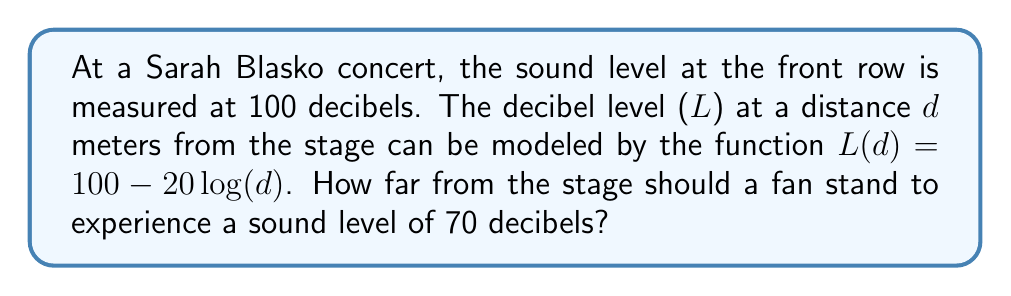Provide a solution to this math problem. Let's approach this step-by-step:

1) We're given the function $L(d) = 100 - 20\log(d)$, where $L$ is the decibel level and $d$ is the distance from the stage in meters.

2) We want to find $d$ when $L = 70$ decibels. So, let's substitute this into our equation:

   $70 = 100 - 20\log(d)$

3) Subtract 100 from both sides:

   $-30 = -20\log(d)$

4) Divide both sides by -20:

   $\frac{3}{2} = \log(d)$

5) To solve for $d$, we need to apply the inverse function of $\log$, which is the exponential function:

   $10^{\frac{3}{2}} = d$

6) Calculate this value:

   $d = 10^{1.5} \approx 31.62$ meters

Therefore, a fan should stand approximately 31.62 meters from the stage to experience a sound level of 70 decibels.
Answer: $31.62$ meters 